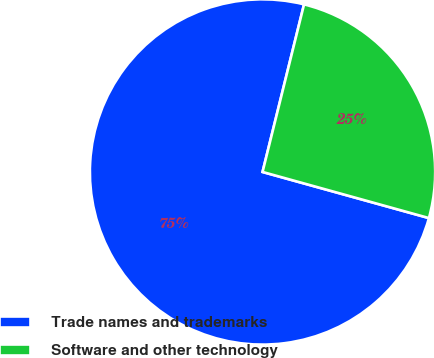Convert chart. <chart><loc_0><loc_0><loc_500><loc_500><pie_chart><fcel>Trade names and trademarks<fcel>Software and other technology<nl><fcel>74.56%<fcel>25.44%<nl></chart> 